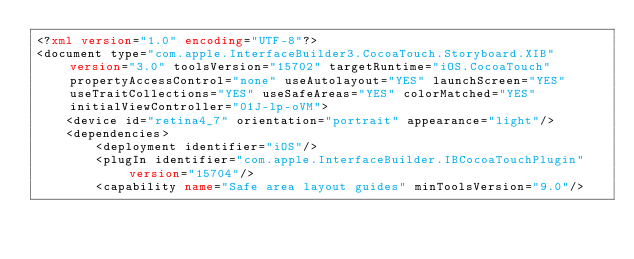<code> <loc_0><loc_0><loc_500><loc_500><_XML_><?xml version="1.0" encoding="UTF-8"?>
<document type="com.apple.InterfaceBuilder3.CocoaTouch.Storyboard.XIB" version="3.0" toolsVersion="15702" targetRuntime="iOS.CocoaTouch" propertyAccessControl="none" useAutolayout="YES" launchScreen="YES" useTraitCollections="YES" useSafeAreas="YES" colorMatched="YES" initialViewController="01J-lp-oVM">
    <device id="retina4_7" orientation="portrait" appearance="light"/>
    <dependencies>
        <deployment identifier="iOS"/>
        <plugIn identifier="com.apple.InterfaceBuilder.IBCocoaTouchPlugin" version="15704"/>
        <capability name="Safe area layout guides" minToolsVersion="9.0"/></code> 